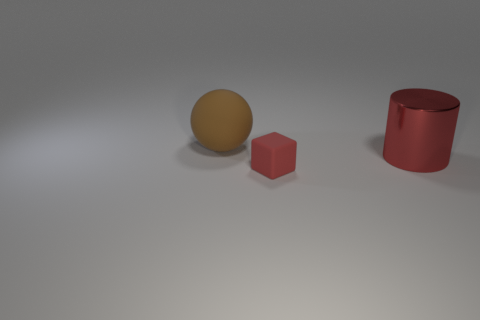What number of rubber blocks are the same color as the large metal cylinder?
Give a very brief answer. 1. There is a red thing that is behind the red block; is its size the same as the brown matte ball?
Give a very brief answer. Yes. How many objects are red objects in front of the cylinder or big rubber things?
Make the answer very short. 2. Are there any other rubber balls that have the same size as the brown ball?
Ensure brevity in your answer.  No. There is a cylinder that is the same size as the matte ball; what is it made of?
Ensure brevity in your answer.  Metal. What is the shape of the thing that is in front of the big matte thing and behind the small block?
Provide a succinct answer. Cylinder. What color is the metal cylinder that is behind the small red matte object?
Your answer should be compact. Red. There is a thing that is in front of the matte sphere and behind the tiny block; what size is it?
Your answer should be compact. Large. Is the tiny thing made of the same material as the red thing that is behind the red rubber thing?
Give a very brief answer. No. What material is the cylinder that is the same color as the matte cube?
Make the answer very short. Metal. 